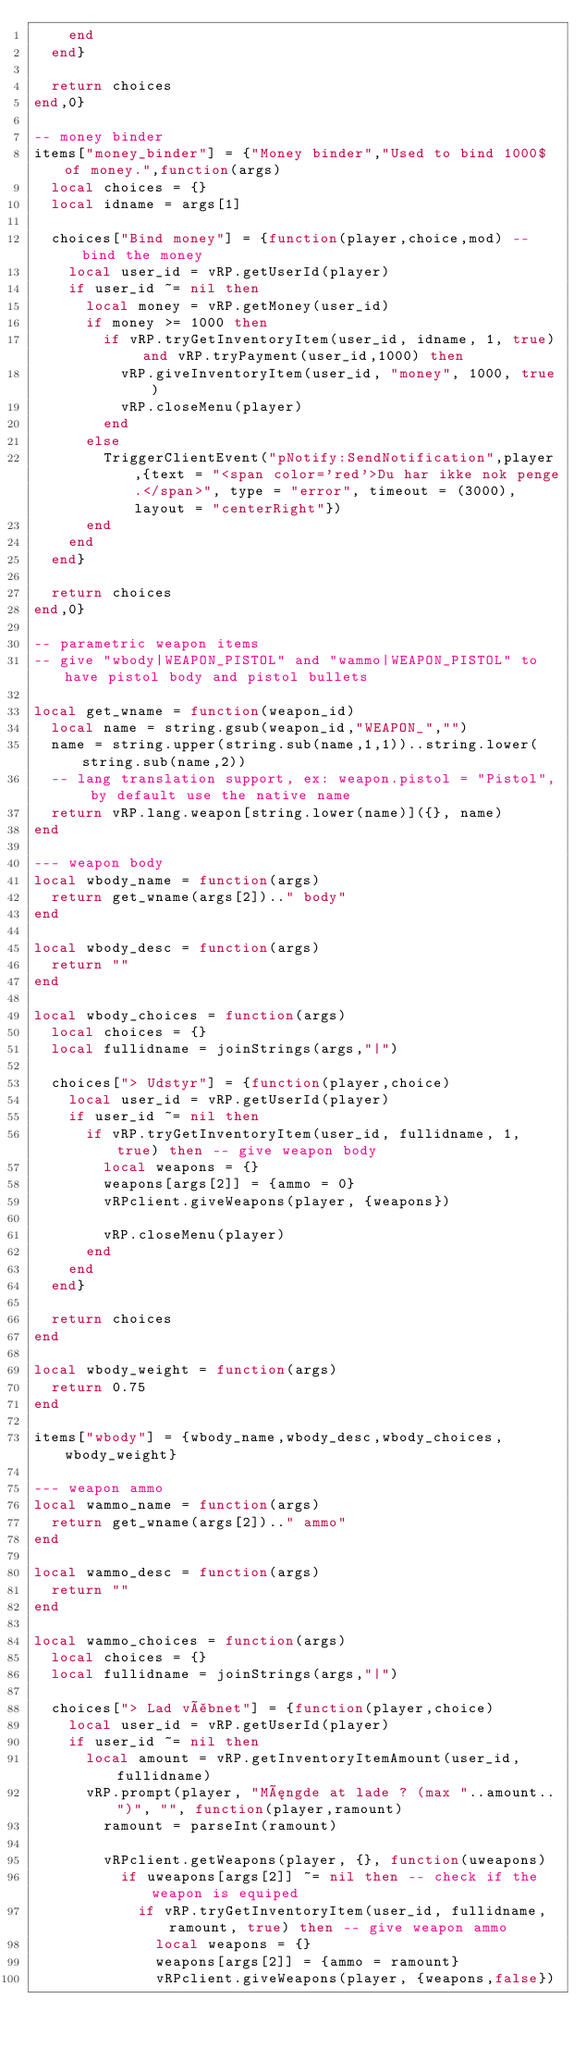Convert code to text. <code><loc_0><loc_0><loc_500><loc_500><_Lua_>		end
	end}

	return choices
end,0}

-- money binder
items["money_binder"] = {"Money binder","Used to bind 1000$ of money.",function(args)
	local choices = {}
	local idname = args[1]

	choices["Bind money"] = {function(player,choice,mod) -- bind the money
		local user_id = vRP.getUserId(player)
		if user_id ~= nil then
			local money = vRP.getMoney(user_id)
			if money >= 1000 then
				if vRP.tryGetInventoryItem(user_id, idname, 1, true) and vRP.tryPayment(user_id,1000) then
					vRP.giveInventoryItem(user_id, "money", 1000, true)
					vRP.closeMenu(player)
				end
			else
				TriggerClientEvent("pNotify:SendNotification",player,{text = "<span color='red'>Du har ikke nok penge.</span>", type = "error", timeout = (3000),layout = "centerRight"})
			end
		end
	end}

	return choices
end,0}

-- parametric weapon items
-- give "wbody|WEAPON_PISTOL" and "wammo|WEAPON_PISTOL" to have pistol body and pistol bullets

local get_wname = function(weapon_id)
	local name = string.gsub(weapon_id,"WEAPON_","")
	name = string.upper(string.sub(name,1,1))..string.lower(string.sub(name,2))
	-- lang translation support, ex: weapon.pistol = "Pistol", by default use the native name
	return vRP.lang.weapon[string.lower(name)]({}, name)
end

--- weapon body
local wbody_name = function(args)
	return get_wname(args[2]).." body"
end

local wbody_desc = function(args)
	return ""
end

local wbody_choices = function(args)
	local choices = {}
	local fullidname = joinStrings(args,"|")

	choices["> Udstyr"] = {function(player,choice)
		local user_id = vRP.getUserId(player)
		if user_id ~= nil then
			if vRP.tryGetInventoryItem(user_id, fullidname, 1, true) then -- give weapon body
				local weapons = {}
				weapons[args[2]] = {ammo = 0}
				vRPclient.giveWeapons(player, {weapons})

				vRP.closeMenu(player)
			end
		end
	end}

	return choices
end

local wbody_weight = function(args)
	return 0.75
end

items["wbody"] = {wbody_name,wbody_desc,wbody_choices,wbody_weight}

--- weapon ammo
local wammo_name = function(args)
	return get_wname(args[2]).." ammo"
end

local wammo_desc = function(args)
	return ""
end

local wammo_choices = function(args)
	local choices = {}
	local fullidname = joinStrings(args,"|")

	choices["> Lad våbnet"] = {function(player,choice)
		local user_id = vRP.getUserId(player)
		if user_id ~= nil then
			local amount = vRP.getInventoryItemAmount(user_id, fullidname)
			vRP.prompt(player, "Mængde at lade ? (max "..amount..")", "", function(player,ramount)
				ramount = parseInt(ramount)

				vRPclient.getWeapons(player, {}, function(uweapons)
					if uweapons[args[2]] ~= nil then -- check if the weapon is equiped
						if vRP.tryGetInventoryItem(user_id, fullidname, ramount, true) then -- give weapon ammo
							local weapons = {}
							weapons[args[2]] = {ammo = ramount}
							vRPclient.giveWeapons(player, {weapons,false})</code> 